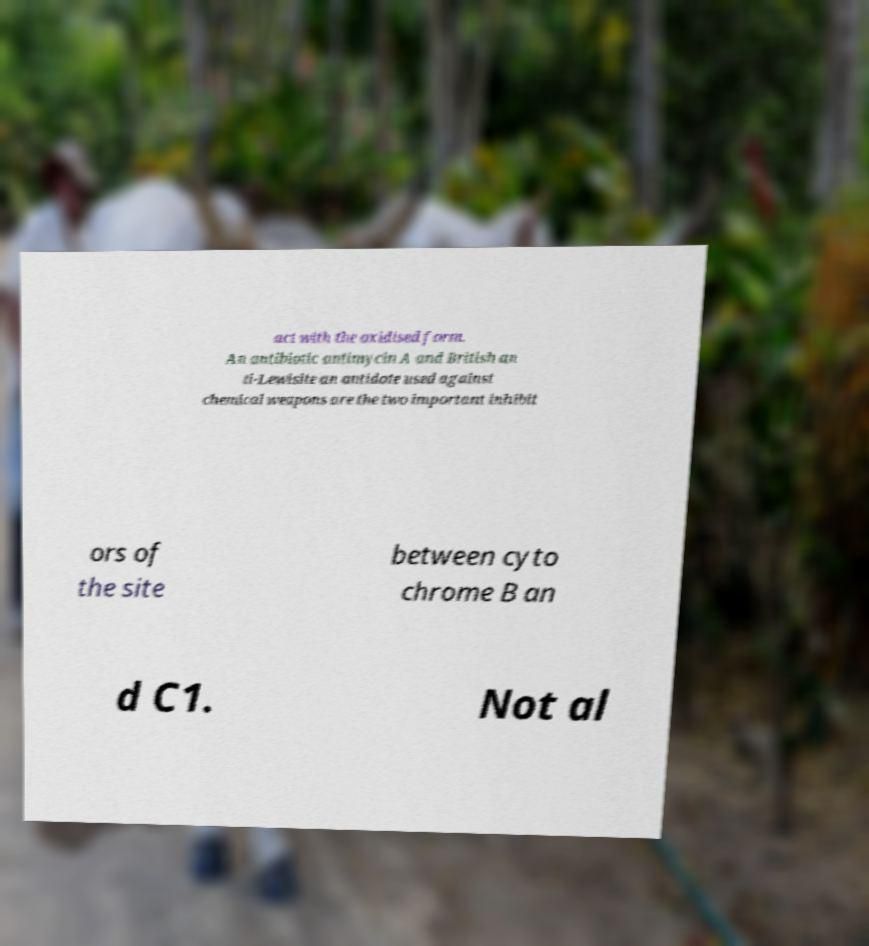I need the written content from this picture converted into text. Can you do that? act with the oxidised form. An antibiotic antimycin A and British an ti-Lewisite an antidote used against chemical weapons are the two important inhibit ors of the site between cyto chrome B an d C1. Not al 